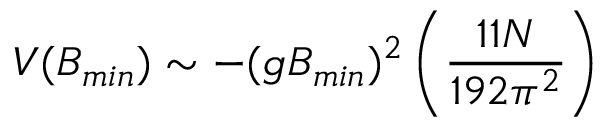<formula> <loc_0><loc_0><loc_500><loc_500>V ( B _ { \min } ) \sim - ( g B _ { \min } ) ^ { 2 } \left ( \frac { 1 1 N } { 1 9 2 \pi ^ { 2 } } \right )</formula> 